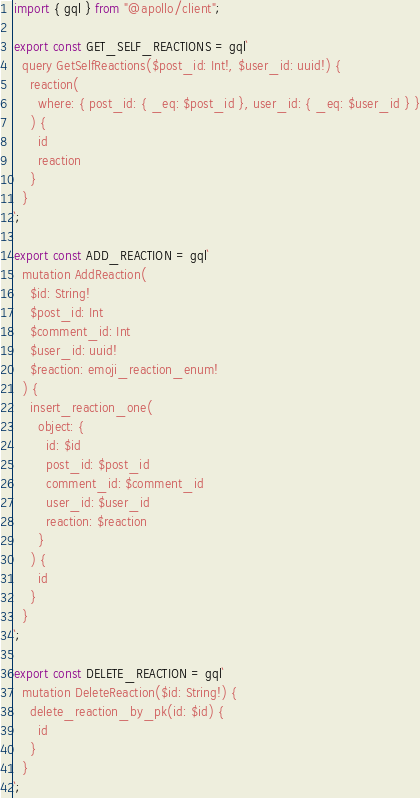<code> <loc_0><loc_0><loc_500><loc_500><_TypeScript_>import { gql } from "@apollo/client";

export const GET_SELF_REACTIONS = gql`
  query GetSelfReactions($post_id: Int!, $user_id: uuid!) {
    reaction(
      where: { post_id: { _eq: $post_id }, user_id: { _eq: $user_id } }
    ) {
      id
      reaction
    }
  }
`;

export const ADD_REACTION = gql`
  mutation AddReaction(
    $id: String!
    $post_id: Int
    $comment_id: Int
    $user_id: uuid!
    $reaction: emoji_reaction_enum!
  ) {
    insert_reaction_one(
      object: {
        id: $id
        post_id: $post_id
        comment_id: $comment_id
        user_id: $user_id
        reaction: $reaction
      }
    ) {
      id
    }
  }
`;

export const DELETE_REACTION = gql`
  mutation DeleteReaction($id: String!) {
    delete_reaction_by_pk(id: $id) {
      id
    }
  }
`;
</code> 